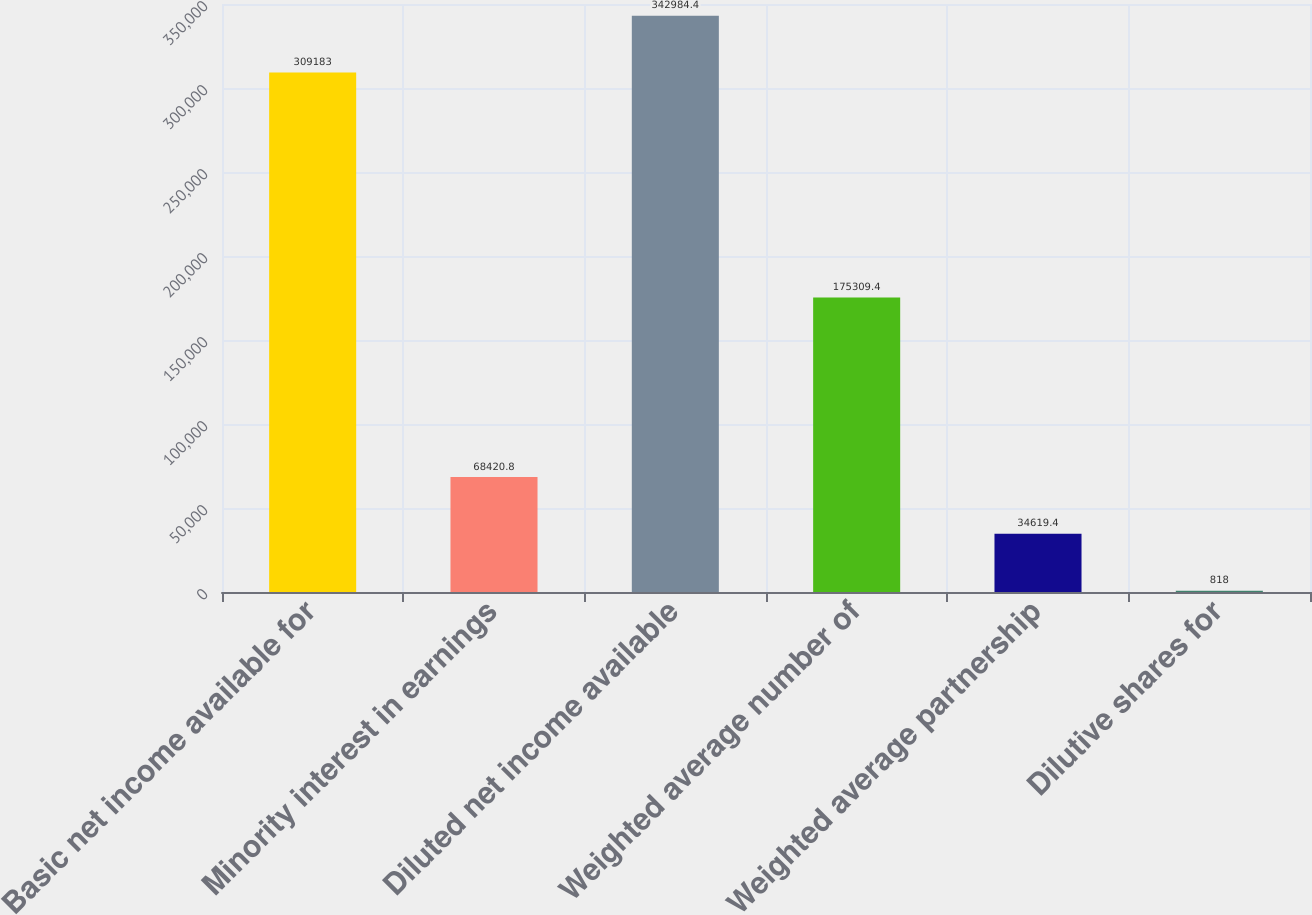<chart> <loc_0><loc_0><loc_500><loc_500><bar_chart><fcel>Basic net income available for<fcel>Minority interest in earnings<fcel>Diluted net income available<fcel>Weighted average number of<fcel>Weighted average partnership<fcel>Dilutive shares for<nl><fcel>309183<fcel>68420.8<fcel>342984<fcel>175309<fcel>34619.4<fcel>818<nl></chart> 